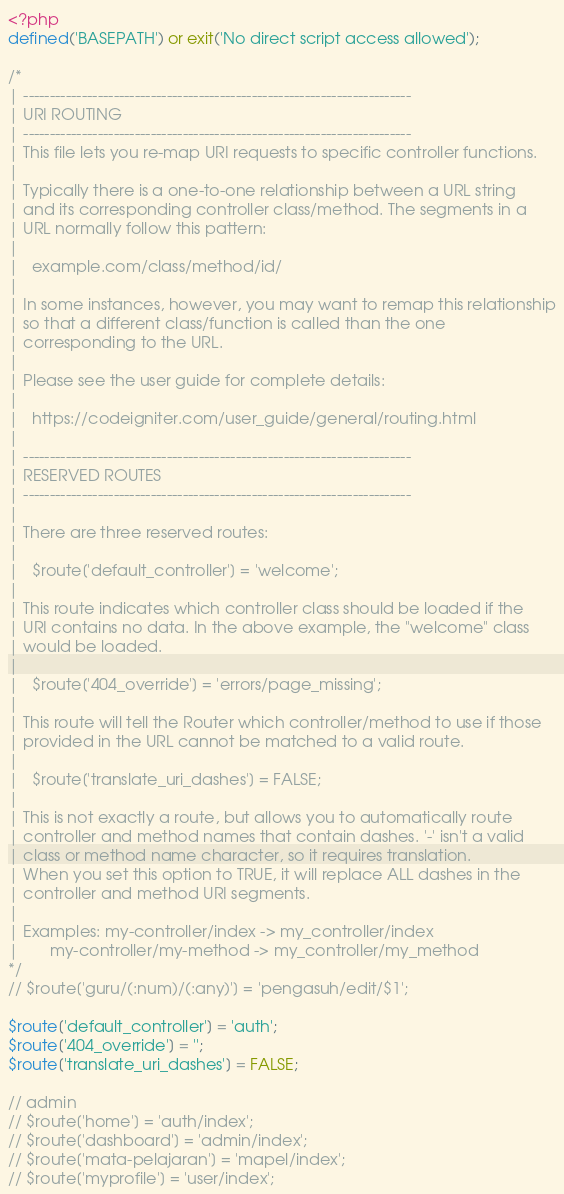<code> <loc_0><loc_0><loc_500><loc_500><_PHP_><?php
defined('BASEPATH') or exit('No direct script access allowed');

/*
| -------------------------------------------------------------------------
| URI ROUTING
| -------------------------------------------------------------------------
| This file lets you re-map URI requests to specific controller functions.
|
| Typically there is a one-to-one relationship between a URL string
| and its corresponding controller class/method. The segments in a
| URL normally follow this pattern:
|
|	example.com/class/method/id/
|
| In some instances, however, you may want to remap this relationship
| so that a different class/function is called than the one
| corresponding to the URL.
|
| Please see the user guide for complete details:
|
|	https://codeigniter.com/user_guide/general/routing.html
|
| -------------------------------------------------------------------------
| RESERVED ROUTES
| -------------------------------------------------------------------------
|
| There are three reserved routes:
|
|	$route['default_controller'] = 'welcome';
|
| This route indicates which controller class should be loaded if the
| URI contains no data. In the above example, the "welcome" class
| would be loaded.
|
|	$route['404_override'] = 'errors/page_missing';
|
| This route will tell the Router which controller/method to use if those
| provided in the URL cannot be matched to a valid route.
|
|	$route['translate_uri_dashes'] = FALSE;
|
| This is not exactly a route, but allows you to automatically route
| controller and method names that contain dashes. '-' isn't a valid
| class or method name character, so it requires translation.
| When you set this option to TRUE, it will replace ALL dashes in the
| controller and method URI segments.
|
| Examples:	my-controller/index	-> my_controller/index
|		my-controller/my-method	-> my_controller/my_method
*/
// $route['guru/(:num)/(:any)'] = 'pengasuh/edit/$1';

$route['default_controller'] = 'auth';
$route['404_override'] = '';
$route['translate_uri_dashes'] = FALSE;

// admin
// $route['home'] = 'auth/index';
// $route['dashboard'] = 'admin/index';
// $route['mata-pelajaran'] = 'mapel/index';
// $route['myprofile'] = 'user/index';
</code> 